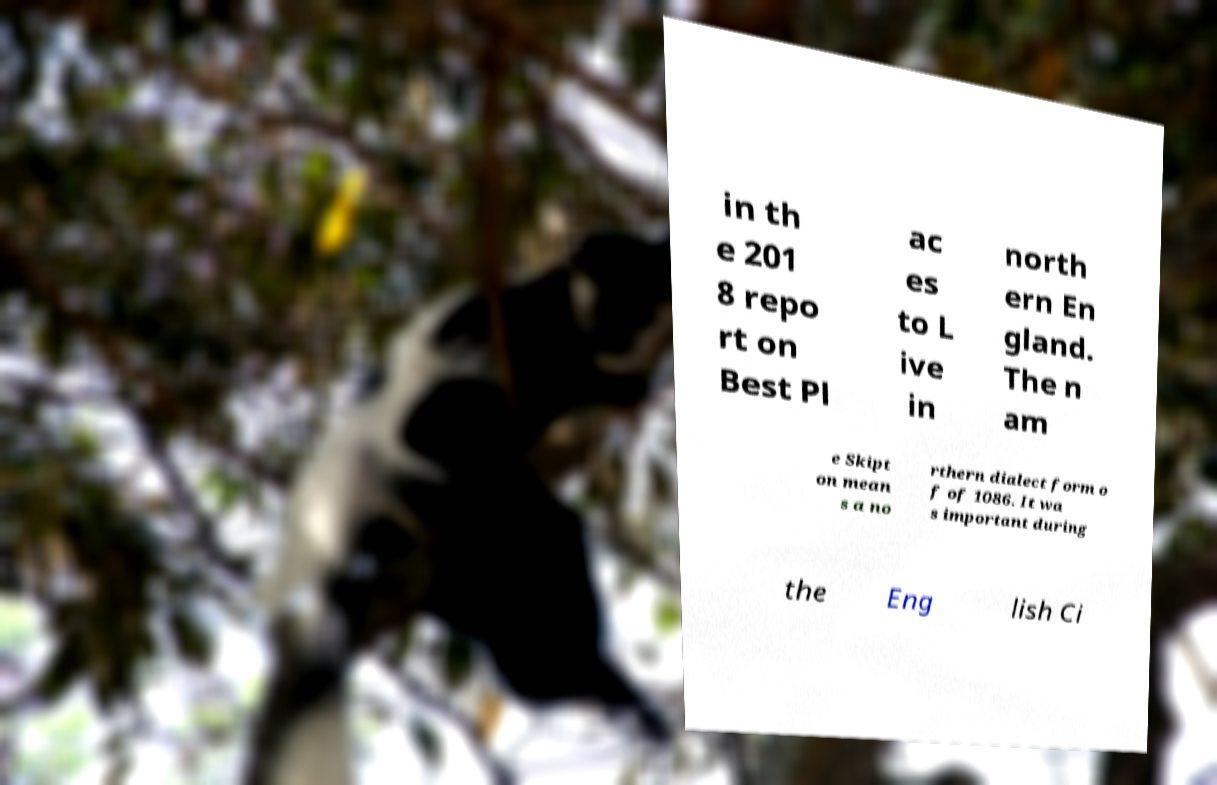There's text embedded in this image that I need extracted. Can you transcribe it verbatim? in th e 201 8 repo rt on Best Pl ac es to L ive in north ern En gland. The n am e Skipt on mean s a no rthern dialect form o f of 1086. It wa s important during the Eng lish Ci 